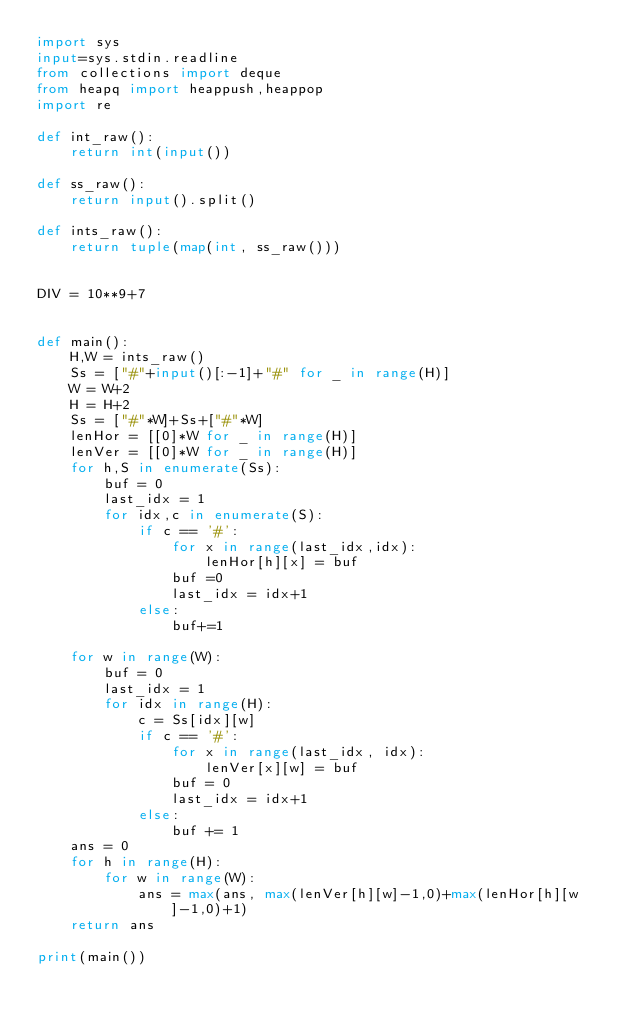<code> <loc_0><loc_0><loc_500><loc_500><_Python_>import sys
input=sys.stdin.readline
from collections import deque
from heapq import heappush,heappop
import re

def int_raw():
    return int(input())
 
def ss_raw():
    return input().split()
 
def ints_raw():
    return tuple(map(int, ss_raw()))


DIV = 10**9+7


def main():
    H,W = ints_raw()
    Ss = ["#"+input()[:-1]+"#" for _ in range(H)]
    W = W+2
    H = H+2
    Ss = ["#"*W]+Ss+["#"*W]
    lenHor = [[0]*W for _ in range(H)]
    lenVer = [[0]*W for _ in range(H)]
    for h,S in enumerate(Ss):
        buf = 0
        last_idx = 1
        for idx,c in enumerate(S):
            if c == '#':
                for x in range(last_idx,idx):
                    lenHor[h][x] = buf
                buf =0
                last_idx = idx+1
            else:
                buf+=1
    
    for w in range(W):
        buf = 0
        last_idx = 1
        for idx in range(H):
            c = Ss[idx][w]
            if c == '#':
                for x in range(last_idx, idx):
                    lenVer[x][w] = buf
                buf = 0
                last_idx = idx+1
            else:
                buf += 1
    ans = 0
    for h in range(H):
        for w in range(W):
            ans = max(ans, max(lenVer[h][w]-1,0)+max(lenHor[h][w]-1,0)+1)
    return ans

print(main())
</code> 